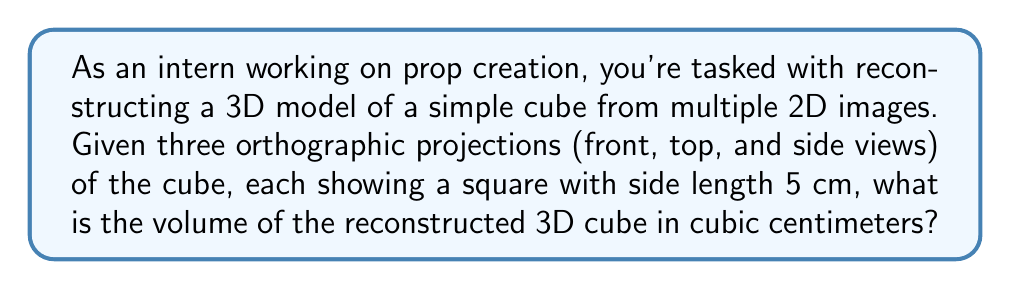What is the answer to this math problem? To solve this problem, let's follow these steps:

1. Understand the given information:
   - We have three orthographic projections of a cube (front, top, and side views).
   - Each projection shows a square with side length 5 cm.

2. Recognize that for a cube, all sides are equal:
   - Since each projection shows a square with side length 5 cm, we can conclude that the cube has equal sides of 5 cm.

3. Calculate the volume of the cube:
   - The formula for the volume of a cube is:
     $$V = s^3$$
   where $V$ is the volume and $s$ is the length of one side.

   - Substituting the side length:
     $$V = (5 \text{ cm})^3$$

   - Calculating the result:
     $$V = 125 \text{ cm}^3$$

Therefore, the volume of the reconstructed 3D cube is 125 cubic centimeters.
Answer: 125 cm³ 